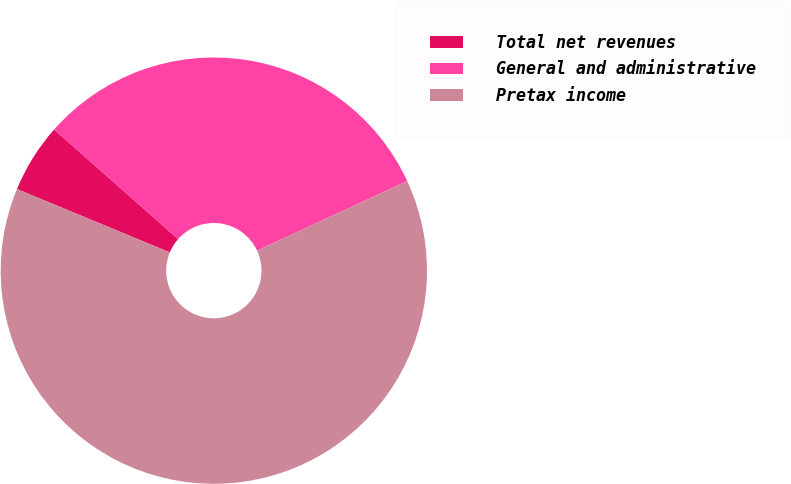<chart> <loc_0><loc_0><loc_500><loc_500><pie_chart><fcel>Total net revenues<fcel>General and administrative<fcel>Pretax income<nl><fcel>5.26%<fcel>31.58%<fcel>63.16%<nl></chart> 